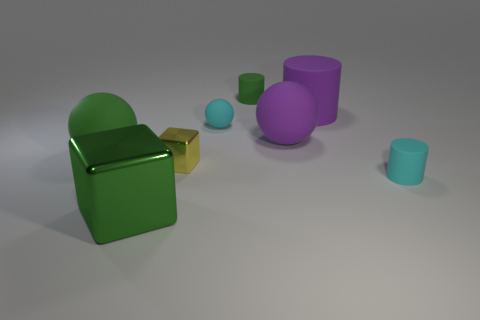Subtract all big purple rubber spheres. How many spheres are left? 2 Add 1 purple cylinders. How many objects exist? 9 Subtract all cylinders. How many objects are left? 5 Subtract 1 cyan cylinders. How many objects are left? 7 Subtract all yellow blocks. Subtract all gray balls. How many blocks are left? 1 Subtract all green rubber objects. Subtract all tiny metallic cubes. How many objects are left? 5 Add 8 cyan objects. How many cyan objects are left? 10 Add 7 large matte objects. How many large matte objects exist? 10 